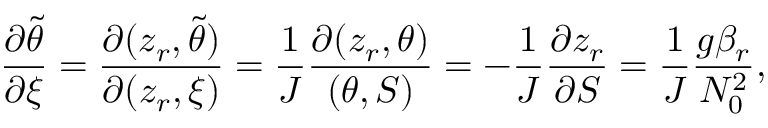<formula> <loc_0><loc_0><loc_500><loc_500>\frac { \partial \tilde { \theta } } { \partial \xi } = \frac { \partial ( z _ { r } , \tilde { \theta } ) } { \partial ( z _ { r } , \xi ) } = \frac { 1 } { J } \frac { \partial ( z _ { r } , \theta ) } { ( \theta , S ) } = - \frac { 1 } { J } \frac { \partial z _ { r } } { \partial S } = \frac { 1 } { J } \frac { g \beta _ { r } } { N _ { 0 } ^ { 2 } } ,</formula> 